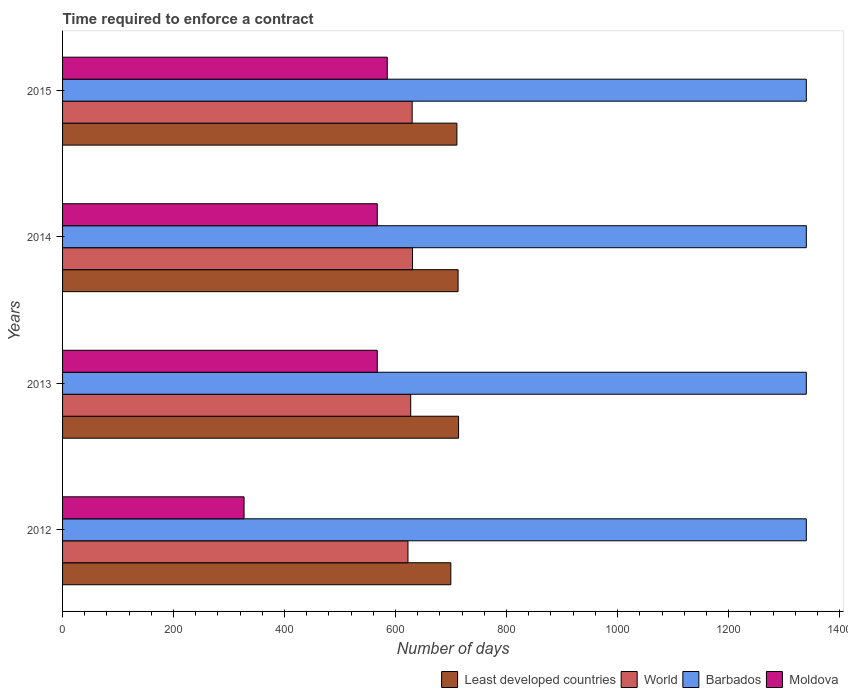How many different coloured bars are there?
Keep it short and to the point. 4. Are the number of bars on each tick of the Y-axis equal?
Ensure brevity in your answer.  Yes. How many bars are there on the 4th tick from the top?
Offer a very short reply. 4. How many bars are there on the 4th tick from the bottom?
Your response must be concise. 4. What is the label of the 4th group of bars from the top?
Provide a succinct answer. 2012. What is the number of days required to enforce a contract in Moldova in 2015?
Give a very brief answer. 585. Across all years, what is the maximum number of days required to enforce a contract in World?
Ensure brevity in your answer.  630.54. Across all years, what is the minimum number of days required to enforce a contract in Least developed countries?
Provide a succinct answer. 699.53. In which year was the number of days required to enforce a contract in World maximum?
Provide a short and direct response. 2014. What is the total number of days required to enforce a contract in Barbados in the graph?
Provide a short and direct response. 5360. What is the difference between the number of days required to enforce a contract in Least developed countries in 2014 and that in 2015?
Your answer should be compact. 2.17. What is the difference between the number of days required to enforce a contract in Barbados in 2014 and the number of days required to enforce a contract in Least developed countries in 2012?
Offer a terse response. 640.47. What is the average number of days required to enforce a contract in Moldova per year?
Give a very brief answer. 511.5. In the year 2014, what is the difference between the number of days required to enforce a contract in World and number of days required to enforce a contract in Barbados?
Your response must be concise. -709.46. What is the ratio of the number of days required to enforce a contract in Least developed countries in 2012 to that in 2014?
Make the answer very short. 0.98. Is the difference between the number of days required to enforce a contract in World in 2012 and 2014 greater than the difference between the number of days required to enforce a contract in Barbados in 2012 and 2014?
Your answer should be compact. No. What is the difference between the highest and the second highest number of days required to enforce a contract in World?
Your answer should be compact. 0.67. What is the difference between the highest and the lowest number of days required to enforce a contract in Moldova?
Ensure brevity in your answer.  258. Is it the case that in every year, the sum of the number of days required to enforce a contract in Moldova and number of days required to enforce a contract in Barbados is greater than the sum of number of days required to enforce a contract in Least developed countries and number of days required to enforce a contract in World?
Provide a succinct answer. No. What does the 3rd bar from the top in 2013 represents?
Offer a terse response. World. What does the 2nd bar from the bottom in 2012 represents?
Ensure brevity in your answer.  World. How many bars are there?
Give a very brief answer. 16. Are all the bars in the graph horizontal?
Keep it short and to the point. Yes. Are the values on the major ticks of X-axis written in scientific E-notation?
Provide a short and direct response. No. Does the graph contain any zero values?
Your response must be concise. No. How many legend labels are there?
Provide a short and direct response. 4. How are the legend labels stacked?
Make the answer very short. Horizontal. What is the title of the graph?
Keep it short and to the point. Time required to enforce a contract. Does "Kazakhstan" appear as one of the legend labels in the graph?
Your answer should be very brief. No. What is the label or title of the X-axis?
Give a very brief answer. Number of days. What is the label or title of the Y-axis?
Give a very brief answer. Years. What is the Number of days in Least developed countries in 2012?
Offer a terse response. 699.53. What is the Number of days of World in 2012?
Your answer should be compact. 622.29. What is the Number of days in Barbados in 2012?
Ensure brevity in your answer.  1340. What is the Number of days of Moldova in 2012?
Make the answer very short. 327. What is the Number of days of Least developed countries in 2013?
Make the answer very short. 713.5. What is the Number of days of World in 2013?
Keep it short and to the point. 627.26. What is the Number of days of Barbados in 2013?
Your answer should be very brief. 1340. What is the Number of days in Moldova in 2013?
Your answer should be compact. 567. What is the Number of days in Least developed countries in 2014?
Ensure brevity in your answer.  712.63. What is the Number of days of World in 2014?
Provide a succinct answer. 630.54. What is the Number of days in Barbados in 2014?
Offer a terse response. 1340. What is the Number of days in Moldova in 2014?
Give a very brief answer. 567. What is the Number of days in Least developed countries in 2015?
Offer a very short reply. 710.46. What is the Number of days of World in 2015?
Give a very brief answer. 629.87. What is the Number of days in Barbados in 2015?
Provide a short and direct response. 1340. What is the Number of days of Moldova in 2015?
Provide a short and direct response. 585. Across all years, what is the maximum Number of days in Least developed countries?
Provide a short and direct response. 713.5. Across all years, what is the maximum Number of days in World?
Provide a succinct answer. 630.54. Across all years, what is the maximum Number of days in Barbados?
Keep it short and to the point. 1340. Across all years, what is the maximum Number of days of Moldova?
Ensure brevity in your answer.  585. Across all years, what is the minimum Number of days in Least developed countries?
Ensure brevity in your answer.  699.53. Across all years, what is the minimum Number of days of World?
Provide a short and direct response. 622.29. Across all years, what is the minimum Number of days of Barbados?
Provide a short and direct response. 1340. Across all years, what is the minimum Number of days of Moldova?
Offer a terse response. 327. What is the total Number of days in Least developed countries in the graph?
Keep it short and to the point. 2836.12. What is the total Number of days in World in the graph?
Provide a short and direct response. 2509.96. What is the total Number of days of Barbados in the graph?
Give a very brief answer. 5360. What is the total Number of days in Moldova in the graph?
Your response must be concise. 2046. What is the difference between the Number of days in Least developed countries in 2012 and that in 2013?
Your answer should be very brief. -13.97. What is the difference between the Number of days of World in 2012 and that in 2013?
Make the answer very short. -4.97. What is the difference between the Number of days of Barbados in 2012 and that in 2013?
Keep it short and to the point. 0. What is the difference between the Number of days in Moldova in 2012 and that in 2013?
Offer a very short reply. -240. What is the difference between the Number of days of Least developed countries in 2012 and that in 2014?
Your answer should be very brief. -13.1. What is the difference between the Number of days of World in 2012 and that in 2014?
Your answer should be compact. -8.25. What is the difference between the Number of days in Moldova in 2012 and that in 2014?
Offer a terse response. -240. What is the difference between the Number of days in Least developed countries in 2012 and that in 2015?
Give a very brief answer. -10.92. What is the difference between the Number of days of World in 2012 and that in 2015?
Provide a succinct answer. -7.59. What is the difference between the Number of days of Barbados in 2012 and that in 2015?
Provide a succinct answer. 0. What is the difference between the Number of days of Moldova in 2012 and that in 2015?
Offer a very short reply. -258. What is the difference between the Number of days in Least developed countries in 2013 and that in 2014?
Offer a terse response. 0.87. What is the difference between the Number of days in World in 2013 and that in 2014?
Your answer should be very brief. -3.28. What is the difference between the Number of days of Barbados in 2013 and that in 2014?
Your answer should be compact. 0. What is the difference between the Number of days of Least developed countries in 2013 and that in 2015?
Provide a short and direct response. 3.04. What is the difference between the Number of days in World in 2013 and that in 2015?
Your answer should be compact. -2.61. What is the difference between the Number of days in Least developed countries in 2014 and that in 2015?
Offer a terse response. 2.17. What is the difference between the Number of days in Barbados in 2014 and that in 2015?
Keep it short and to the point. 0. What is the difference between the Number of days of Least developed countries in 2012 and the Number of days of World in 2013?
Make the answer very short. 72.28. What is the difference between the Number of days in Least developed countries in 2012 and the Number of days in Barbados in 2013?
Your response must be concise. -640.47. What is the difference between the Number of days of Least developed countries in 2012 and the Number of days of Moldova in 2013?
Offer a very short reply. 132.53. What is the difference between the Number of days of World in 2012 and the Number of days of Barbados in 2013?
Offer a very short reply. -717.71. What is the difference between the Number of days of World in 2012 and the Number of days of Moldova in 2013?
Give a very brief answer. 55.29. What is the difference between the Number of days of Barbados in 2012 and the Number of days of Moldova in 2013?
Ensure brevity in your answer.  773. What is the difference between the Number of days of Least developed countries in 2012 and the Number of days of World in 2014?
Provide a succinct answer. 68.99. What is the difference between the Number of days in Least developed countries in 2012 and the Number of days in Barbados in 2014?
Your answer should be very brief. -640.47. What is the difference between the Number of days of Least developed countries in 2012 and the Number of days of Moldova in 2014?
Keep it short and to the point. 132.53. What is the difference between the Number of days in World in 2012 and the Number of days in Barbados in 2014?
Make the answer very short. -717.71. What is the difference between the Number of days in World in 2012 and the Number of days in Moldova in 2014?
Keep it short and to the point. 55.29. What is the difference between the Number of days of Barbados in 2012 and the Number of days of Moldova in 2014?
Offer a terse response. 773. What is the difference between the Number of days of Least developed countries in 2012 and the Number of days of World in 2015?
Ensure brevity in your answer.  69.66. What is the difference between the Number of days in Least developed countries in 2012 and the Number of days in Barbados in 2015?
Offer a terse response. -640.47. What is the difference between the Number of days in Least developed countries in 2012 and the Number of days in Moldova in 2015?
Your response must be concise. 114.53. What is the difference between the Number of days of World in 2012 and the Number of days of Barbados in 2015?
Your response must be concise. -717.71. What is the difference between the Number of days in World in 2012 and the Number of days in Moldova in 2015?
Your answer should be compact. 37.29. What is the difference between the Number of days in Barbados in 2012 and the Number of days in Moldova in 2015?
Keep it short and to the point. 755. What is the difference between the Number of days in Least developed countries in 2013 and the Number of days in World in 2014?
Ensure brevity in your answer.  82.96. What is the difference between the Number of days of Least developed countries in 2013 and the Number of days of Barbados in 2014?
Ensure brevity in your answer.  -626.5. What is the difference between the Number of days in Least developed countries in 2013 and the Number of days in Moldova in 2014?
Keep it short and to the point. 146.5. What is the difference between the Number of days of World in 2013 and the Number of days of Barbados in 2014?
Ensure brevity in your answer.  -712.74. What is the difference between the Number of days in World in 2013 and the Number of days in Moldova in 2014?
Make the answer very short. 60.26. What is the difference between the Number of days of Barbados in 2013 and the Number of days of Moldova in 2014?
Your answer should be compact. 773. What is the difference between the Number of days of Least developed countries in 2013 and the Number of days of World in 2015?
Provide a short and direct response. 83.63. What is the difference between the Number of days in Least developed countries in 2013 and the Number of days in Barbados in 2015?
Offer a very short reply. -626.5. What is the difference between the Number of days in Least developed countries in 2013 and the Number of days in Moldova in 2015?
Your answer should be compact. 128.5. What is the difference between the Number of days in World in 2013 and the Number of days in Barbados in 2015?
Your response must be concise. -712.74. What is the difference between the Number of days in World in 2013 and the Number of days in Moldova in 2015?
Give a very brief answer. 42.26. What is the difference between the Number of days in Barbados in 2013 and the Number of days in Moldova in 2015?
Ensure brevity in your answer.  755. What is the difference between the Number of days of Least developed countries in 2014 and the Number of days of World in 2015?
Ensure brevity in your answer.  82.76. What is the difference between the Number of days of Least developed countries in 2014 and the Number of days of Barbados in 2015?
Your answer should be very brief. -627.37. What is the difference between the Number of days of Least developed countries in 2014 and the Number of days of Moldova in 2015?
Keep it short and to the point. 127.63. What is the difference between the Number of days in World in 2014 and the Number of days in Barbados in 2015?
Provide a short and direct response. -709.46. What is the difference between the Number of days of World in 2014 and the Number of days of Moldova in 2015?
Give a very brief answer. 45.54. What is the difference between the Number of days of Barbados in 2014 and the Number of days of Moldova in 2015?
Provide a succinct answer. 755. What is the average Number of days of Least developed countries per year?
Keep it short and to the point. 709.03. What is the average Number of days in World per year?
Keep it short and to the point. 627.49. What is the average Number of days of Barbados per year?
Offer a terse response. 1340. What is the average Number of days of Moldova per year?
Your answer should be compact. 511.5. In the year 2012, what is the difference between the Number of days in Least developed countries and Number of days in World?
Offer a terse response. 77.25. In the year 2012, what is the difference between the Number of days in Least developed countries and Number of days in Barbados?
Your answer should be compact. -640.47. In the year 2012, what is the difference between the Number of days in Least developed countries and Number of days in Moldova?
Offer a very short reply. 372.53. In the year 2012, what is the difference between the Number of days in World and Number of days in Barbados?
Provide a short and direct response. -717.71. In the year 2012, what is the difference between the Number of days of World and Number of days of Moldova?
Ensure brevity in your answer.  295.29. In the year 2012, what is the difference between the Number of days of Barbados and Number of days of Moldova?
Your answer should be very brief. 1013. In the year 2013, what is the difference between the Number of days of Least developed countries and Number of days of World?
Provide a short and direct response. 86.24. In the year 2013, what is the difference between the Number of days of Least developed countries and Number of days of Barbados?
Your response must be concise. -626.5. In the year 2013, what is the difference between the Number of days in Least developed countries and Number of days in Moldova?
Your response must be concise. 146.5. In the year 2013, what is the difference between the Number of days of World and Number of days of Barbados?
Ensure brevity in your answer.  -712.74. In the year 2013, what is the difference between the Number of days of World and Number of days of Moldova?
Your answer should be compact. 60.26. In the year 2013, what is the difference between the Number of days of Barbados and Number of days of Moldova?
Provide a succinct answer. 773. In the year 2014, what is the difference between the Number of days of Least developed countries and Number of days of World?
Make the answer very short. 82.09. In the year 2014, what is the difference between the Number of days of Least developed countries and Number of days of Barbados?
Give a very brief answer. -627.37. In the year 2014, what is the difference between the Number of days of Least developed countries and Number of days of Moldova?
Provide a succinct answer. 145.63. In the year 2014, what is the difference between the Number of days in World and Number of days in Barbados?
Give a very brief answer. -709.46. In the year 2014, what is the difference between the Number of days of World and Number of days of Moldova?
Provide a short and direct response. 63.54. In the year 2014, what is the difference between the Number of days in Barbados and Number of days in Moldova?
Provide a succinct answer. 773. In the year 2015, what is the difference between the Number of days in Least developed countries and Number of days in World?
Give a very brief answer. 80.58. In the year 2015, what is the difference between the Number of days of Least developed countries and Number of days of Barbados?
Offer a terse response. -629.54. In the year 2015, what is the difference between the Number of days of Least developed countries and Number of days of Moldova?
Keep it short and to the point. 125.46. In the year 2015, what is the difference between the Number of days of World and Number of days of Barbados?
Make the answer very short. -710.13. In the year 2015, what is the difference between the Number of days in World and Number of days in Moldova?
Keep it short and to the point. 44.87. In the year 2015, what is the difference between the Number of days of Barbados and Number of days of Moldova?
Your response must be concise. 755. What is the ratio of the Number of days of Least developed countries in 2012 to that in 2013?
Provide a short and direct response. 0.98. What is the ratio of the Number of days in World in 2012 to that in 2013?
Give a very brief answer. 0.99. What is the ratio of the Number of days in Moldova in 2012 to that in 2013?
Keep it short and to the point. 0.58. What is the ratio of the Number of days of Least developed countries in 2012 to that in 2014?
Keep it short and to the point. 0.98. What is the ratio of the Number of days of World in 2012 to that in 2014?
Provide a short and direct response. 0.99. What is the ratio of the Number of days of Moldova in 2012 to that in 2014?
Keep it short and to the point. 0.58. What is the ratio of the Number of days in Least developed countries in 2012 to that in 2015?
Ensure brevity in your answer.  0.98. What is the ratio of the Number of days of Barbados in 2012 to that in 2015?
Offer a terse response. 1. What is the ratio of the Number of days of Moldova in 2012 to that in 2015?
Make the answer very short. 0.56. What is the ratio of the Number of days of Least developed countries in 2013 to that in 2014?
Offer a terse response. 1. What is the ratio of the Number of days in World in 2013 to that in 2014?
Make the answer very short. 0.99. What is the ratio of the Number of days in World in 2013 to that in 2015?
Make the answer very short. 1. What is the ratio of the Number of days in Moldova in 2013 to that in 2015?
Offer a very short reply. 0.97. What is the ratio of the Number of days in Least developed countries in 2014 to that in 2015?
Your answer should be compact. 1. What is the ratio of the Number of days of World in 2014 to that in 2015?
Make the answer very short. 1. What is the ratio of the Number of days in Moldova in 2014 to that in 2015?
Ensure brevity in your answer.  0.97. What is the difference between the highest and the second highest Number of days of Least developed countries?
Offer a very short reply. 0.87. What is the difference between the highest and the second highest Number of days in World?
Offer a terse response. 0.67. What is the difference between the highest and the second highest Number of days in Moldova?
Make the answer very short. 18. What is the difference between the highest and the lowest Number of days in Least developed countries?
Provide a short and direct response. 13.97. What is the difference between the highest and the lowest Number of days of World?
Your response must be concise. 8.25. What is the difference between the highest and the lowest Number of days in Moldova?
Provide a succinct answer. 258. 